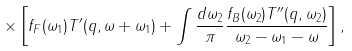Convert formula to latex. <formula><loc_0><loc_0><loc_500><loc_500>\times \left [ f _ { F } ( \omega _ { 1 } ) T ^ { \prime } ( { q } , \omega + \omega _ { 1 } ) + \int \frac { d \omega _ { 2 } } { \pi } \frac { f _ { B } ( \omega _ { 2 } ) T ^ { \prime \prime } ( { q } , \omega _ { 2 } ) } { \omega _ { 2 } - \omega _ { 1 } - \omega } \right ] ,</formula> 